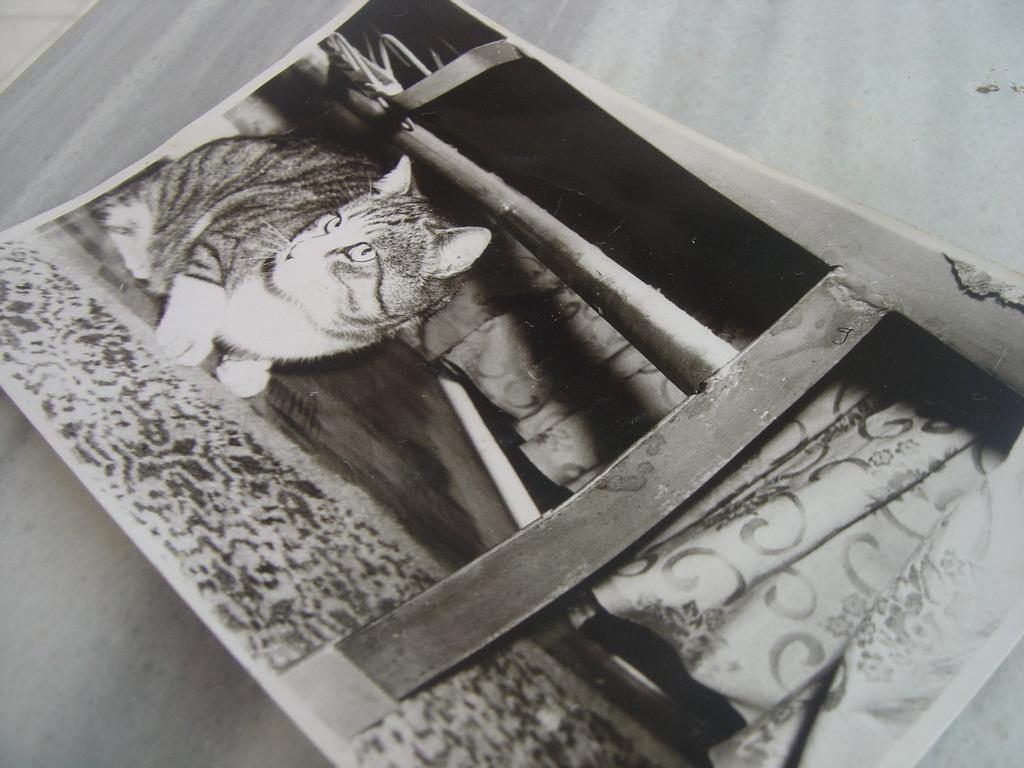Can you describe this image briefly? This is a black and white image where we can see a photograph on the wooden surface. We can see a cat, a table and curtain on the photograph. 